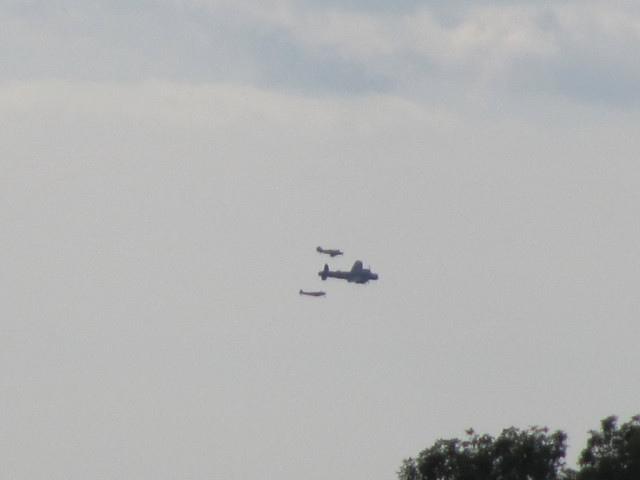What is flying in the sky?
Write a very short answer. Planes. How high is the plane?
Concise answer only. Very high. What color is the sky?
Write a very short answer. Gray. What is in the air?
Write a very short answer. Planes. How many planes?
Write a very short answer. 3. What is the weather like?
Answer briefly. Cloudy. Can you see the  pilots?
Answer briefly. No. What is on the sky?
Concise answer only. Planes. What is in the sky?
Concise answer only. Planes. Is the plane a jet plane?
Keep it brief. No. Is this a balloon?
Short answer required. No. How many planes are in the sky?
Give a very brief answer. 3. What is this person doing?
Quick response, please. Flying. 